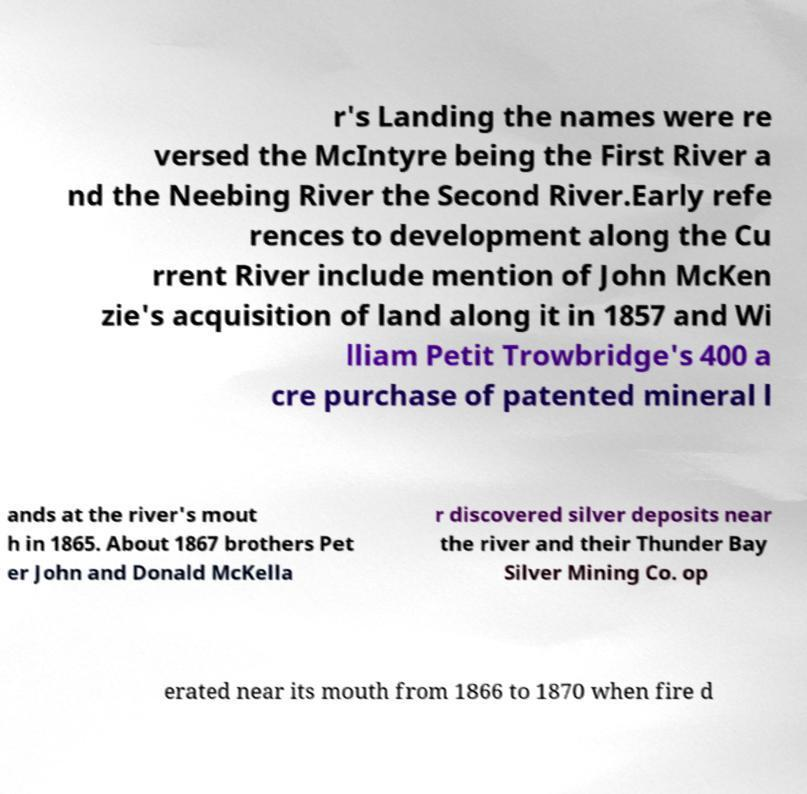Could you extract and type out the text from this image? r's Landing the names were re versed the McIntyre being the First River a nd the Neebing River the Second River.Early refe rences to development along the Cu rrent River include mention of John McKen zie's acquisition of land along it in 1857 and Wi lliam Petit Trowbridge's 400 a cre purchase of patented mineral l ands at the river's mout h in 1865. About 1867 brothers Pet er John and Donald McKella r discovered silver deposits near the river and their Thunder Bay Silver Mining Co. op erated near its mouth from 1866 to 1870 when fire d 